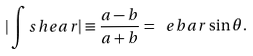Convert formula to latex. <formula><loc_0><loc_0><loc_500><loc_500>| \int s h e a r | \equiv \frac { a - b } { a + b } = \ e b a r \sin \theta .</formula> 